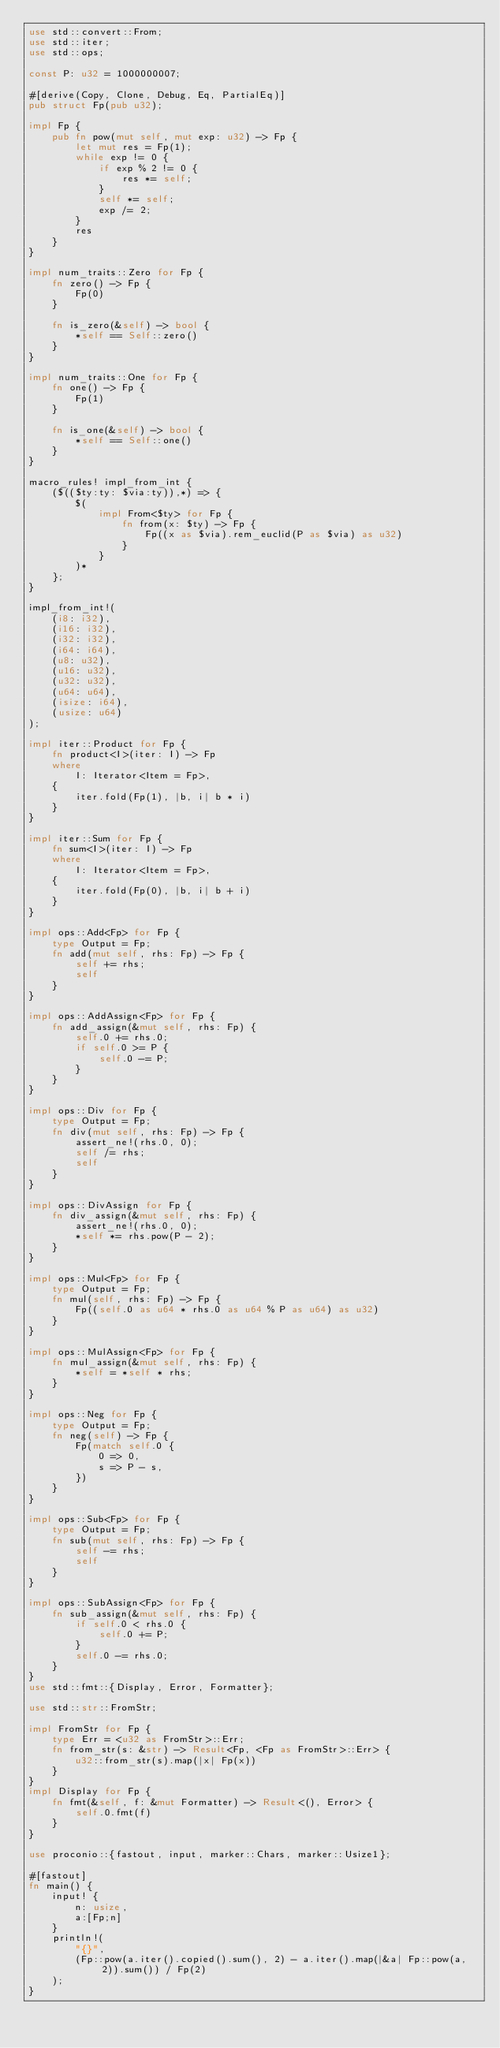Convert code to text. <code><loc_0><loc_0><loc_500><loc_500><_Rust_>use std::convert::From;
use std::iter;
use std::ops;

const P: u32 = 1000000007;

#[derive(Copy, Clone, Debug, Eq, PartialEq)]
pub struct Fp(pub u32);

impl Fp {
    pub fn pow(mut self, mut exp: u32) -> Fp {
        let mut res = Fp(1);
        while exp != 0 {
            if exp % 2 != 0 {
                res *= self;
            }
            self *= self;
            exp /= 2;
        }
        res
    }
}

impl num_traits::Zero for Fp {
    fn zero() -> Fp {
        Fp(0)
    }

    fn is_zero(&self) -> bool {
        *self == Self::zero()
    }
}

impl num_traits::One for Fp {
    fn one() -> Fp {
        Fp(1)
    }

    fn is_one(&self) -> bool {
        *self == Self::one()
    }
}

macro_rules! impl_from_int {
    ($(($ty:ty: $via:ty)),*) => {
        $(
            impl From<$ty> for Fp {
                fn from(x: $ty) -> Fp {
                    Fp((x as $via).rem_euclid(P as $via) as u32)
                }
            }
        )*
    };
}

impl_from_int!(
    (i8: i32),
    (i16: i32),
    (i32: i32),
    (i64: i64),
    (u8: u32),
    (u16: u32),
    (u32: u32),
    (u64: u64),
    (isize: i64),
    (usize: u64)
);

impl iter::Product for Fp {
    fn product<I>(iter: I) -> Fp
    where
        I: Iterator<Item = Fp>,
    {
        iter.fold(Fp(1), |b, i| b * i)
    }
}

impl iter::Sum for Fp {
    fn sum<I>(iter: I) -> Fp
    where
        I: Iterator<Item = Fp>,
    {
        iter.fold(Fp(0), |b, i| b + i)
    }
}

impl ops::Add<Fp> for Fp {
    type Output = Fp;
    fn add(mut self, rhs: Fp) -> Fp {
        self += rhs;
        self
    }
}

impl ops::AddAssign<Fp> for Fp {
    fn add_assign(&mut self, rhs: Fp) {
        self.0 += rhs.0;
        if self.0 >= P {
            self.0 -= P;
        }
    }
}

impl ops::Div for Fp {
    type Output = Fp;
    fn div(mut self, rhs: Fp) -> Fp {
        assert_ne!(rhs.0, 0);
        self /= rhs;
        self
    }
}

impl ops::DivAssign for Fp {
    fn div_assign(&mut self, rhs: Fp) {
        assert_ne!(rhs.0, 0);
        *self *= rhs.pow(P - 2);
    }
}

impl ops::Mul<Fp> for Fp {
    type Output = Fp;
    fn mul(self, rhs: Fp) -> Fp {
        Fp((self.0 as u64 * rhs.0 as u64 % P as u64) as u32)
    }
}

impl ops::MulAssign<Fp> for Fp {
    fn mul_assign(&mut self, rhs: Fp) {
        *self = *self * rhs;
    }
}

impl ops::Neg for Fp {
    type Output = Fp;
    fn neg(self) -> Fp {
        Fp(match self.0 {
            0 => 0,
            s => P - s,
        })
    }
}

impl ops::Sub<Fp> for Fp {
    type Output = Fp;
    fn sub(mut self, rhs: Fp) -> Fp {
        self -= rhs;
        self
    }
}

impl ops::SubAssign<Fp> for Fp {
    fn sub_assign(&mut self, rhs: Fp) {
        if self.0 < rhs.0 {
            self.0 += P;
        }
        self.0 -= rhs.0;
    }
}
use std::fmt::{Display, Error, Formatter};

use std::str::FromStr;

impl FromStr for Fp {
    type Err = <u32 as FromStr>::Err;
    fn from_str(s: &str) -> Result<Fp, <Fp as FromStr>::Err> {
        u32::from_str(s).map(|x| Fp(x))
    }
}
impl Display for Fp {
    fn fmt(&self, f: &mut Formatter) -> Result<(), Error> {
        self.0.fmt(f)
    }
}

use proconio::{fastout, input, marker::Chars, marker::Usize1};

#[fastout]
fn main() {
    input! {
        n: usize,
        a:[Fp;n]
    }
    println!(
        "{}",
        (Fp::pow(a.iter().copied().sum(), 2) - a.iter().map(|&a| Fp::pow(a, 2)).sum()) / Fp(2)
    );
}
</code> 